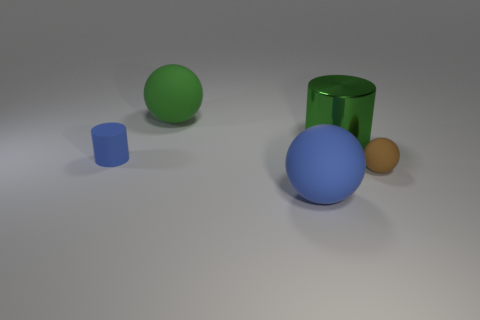Add 1 small cyan matte cylinders. How many objects exist? 6 Subtract all balls. How many objects are left? 2 Add 3 metal objects. How many metal objects exist? 4 Subtract 0 purple spheres. How many objects are left? 5 Subtract all metallic objects. Subtract all big objects. How many objects are left? 1 Add 1 big green rubber things. How many big green rubber things are left? 2 